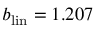<formula> <loc_0><loc_0><loc_500><loc_500>b _ { l i n } = 1 . 2 0 7</formula> 